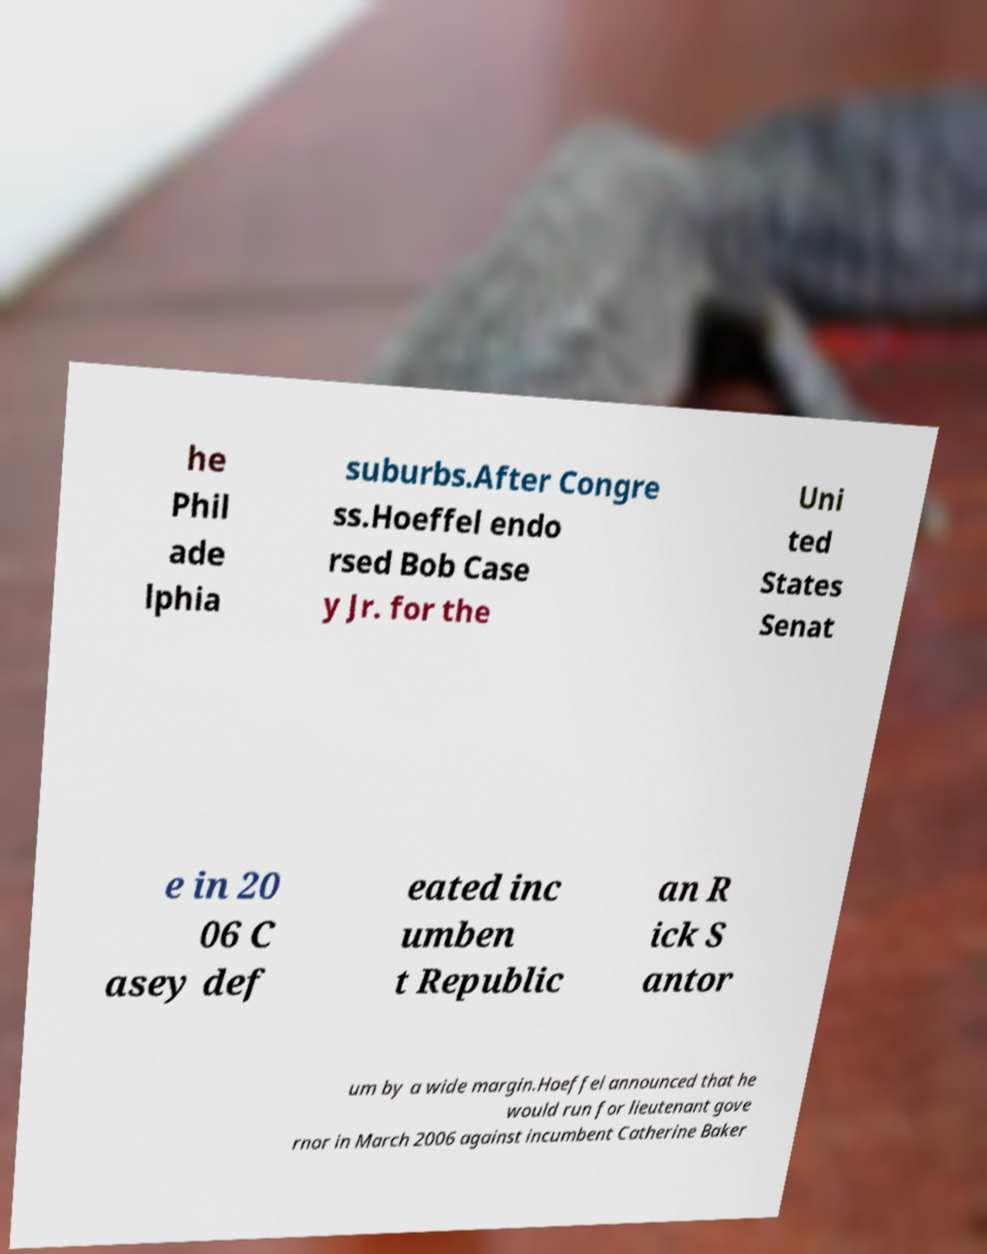Can you read and provide the text displayed in the image?This photo seems to have some interesting text. Can you extract and type it out for me? he Phil ade lphia suburbs.After Congre ss.Hoeffel endo rsed Bob Case y Jr. for the Uni ted States Senat e in 20 06 C asey def eated inc umben t Republic an R ick S antor um by a wide margin.Hoeffel announced that he would run for lieutenant gove rnor in March 2006 against incumbent Catherine Baker 